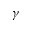Convert formula to latex. <formula><loc_0><loc_0><loc_500><loc_500>\gamma</formula> 